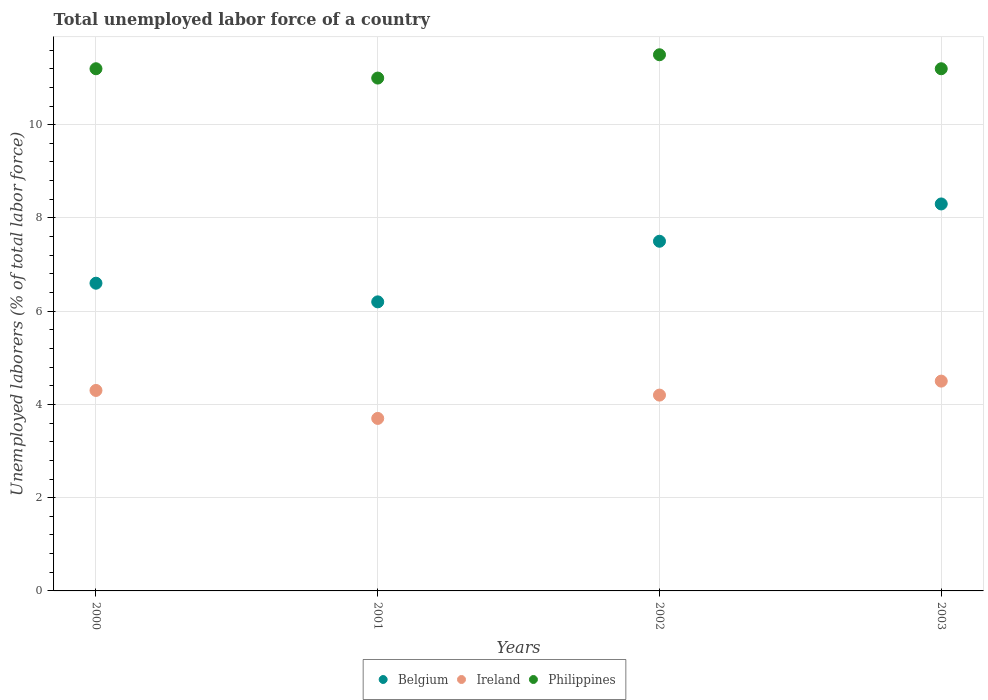How many different coloured dotlines are there?
Your answer should be compact. 3. What is the total unemployed labor force in Ireland in 2000?
Offer a terse response. 4.3. Across all years, what is the maximum total unemployed labor force in Belgium?
Ensure brevity in your answer.  8.3. In which year was the total unemployed labor force in Philippines minimum?
Offer a very short reply. 2001. What is the total total unemployed labor force in Philippines in the graph?
Make the answer very short. 44.9. What is the difference between the total unemployed labor force in Philippines in 2000 and that in 2002?
Your response must be concise. -0.3. What is the difference between the total unemployed labor force in Ireland in 2002 and the total unemployed labor force in Philippines in 2003?
Make the answer very short. -7. What is the average total unemployed labor force in Belgium per year?
Your response must be concise. 7.15. In the year 2000, what is the difference between the total unemployed labor force in Belgium and total unemployed labor force in Philippines?
Give a very brief answer. -4.6. In how many years, is the total unemployed labor force in Philippines greater than 10.4 %?
Your response must be concise. 4. What is the ratio of the total unemployed labor force in Philippines in 2001 to that in 2003?
Make the answer very short. 0.98. Is the difference between the total unemployed labor force in Belgium in 2000 and 2002 greater than the difference between the total unemployed labor force in Philippines in 2000 and 2002?
Provide a succinct answer. No. What is the difference between the highest and the second highest total unemployed labor force in Belgium?
Your answer should be compact. 0.8. What is the difference between the highest and the lowest total unemployed labor force in Belgium?
Your answer should be very brief. 2.1. Is the sum of the total unemployed labor force in Ireland in 2001 and 2002 greater than the maximum total unemployed labor force in Philippines across all years?
Offer a very short reply. No. Is it the case that in every year, the sum of the total unemployed labor force in Philippines and total unemployed labor force in Ireland  is greater than the total unemployed labor force in Belgium?
Keep it short and to the point. Yes. Does the total unemployed labor force in Ireland monotonically increase over the years?
Keep it short and to the point. No. How many years are there in the graph?
Your answer should be very brief. 4. What is the difference between two consecutive major ticks on the Y-axis?
Your answer should be very brief. 2. Are the values on the major ticks of Y-axis written in scientific E-notation?
Your answer should be very brief. No. Where does the legend appear in the graph?
Offer a terse response. Bottom center. What is the title of the graph?
Your response must be concise. Total unemployed labor force of a country. Does "Bermuda" appear as one of the legend labels in the graph?
Keep it short and to the point. No. What is the label or title of the X-axis?
Offer a very short reply. Years. What is the label or title of the Y-axis?
Offer a terse response. Unemployed laborers (% of total labor force). What is the Unemployed laborers (% of total labor force) in Belgium in 2000?
Ensure brevity in your answer.  6.6. What is the Unemployed laborers (% of total labor force) of Ireland in 2000?
Your answer should be compact. 4.3. What is the Unemployed laborers (% of total labor force) in Philippines in 2000?
Your answer should be compact. 11.2. What is the Unemployed laborers (% of total labor force) of Belgium in 2001?
Provide a succinct answer. 6.2. What is the Unemployed laborers (% of total labor force) in Ireland in 2001?
Your answer should be very brief. 3.7. What is the Unemployed laborers (% of total labor force) of Ireland in 2002?
Keep it short and to the point. 4.2. What is the Unemployed laborers (% of total labor force) in Philippines in 2002?
Offer a very short reply. 11.5. What is the Unemployed laborers (% of total labor force) in Belgium in 2003?
Provide a succinct answer. 8.3. What is the Unemployed laborers (% of total labor force) in Ireland in 2003?
Keep it short and to the point. 4.5. What is the Unemployed laborers (% of total labor force) of Philippines in 2003?
Keep it short and to the point. 11.2. Across all years, what is the maximum Unemployed laborers (% of total labor force) of Belgium?
Offer a very short reply. 8.3. Across all years, what is the maximum Unemployed laborers (% of total labor force) of Ireland?
Offer a terse response. 4.5. Across all years, what is the maximum Unemployed laborers (% of total labor force) in Philippines?
Ensure brevity in your answer.  11.5. Across all years, what is the minimum Unemployed laborers (% of total labor force) in Belgium?
Provide a succinct answer. 6.2. Across all years, what is the minimum Unemployed laborers (% of total labor force) of Ireland?
Your answer should be very brief. 3.7. What is the total Unemployed laborers (% of total labor force) of Belgium in the graph?
Make the answer very short. 28.6. What is the total Unemployed laborers (% of total labor force) in Ireland in the graph?
Make the answer very short. 16.7. What is the total Unemployed laborers (% of total labor force) in Philippines in the graph?
Your answer should be very brief. 44.9. What is the difference between the Unemployed laborers (% of total labor force) of Belgium in 2000 and that in 2002?
Provide a succinct answer. -0.9. What is the difference between the Unemployed laborers (% of total labor force) of Belgium in 2000 and that in 2003?
Give a very brief answer. -1.7. What is the difference between the Unemployed laborers (% of total labor force) of Ireland in 2000 and that in 2003?
Make the answer very short. -0.2. What is the difference between the Unemployed laborers (% of total labor force) of Belgium in 2001 and that in 2002?
Offer a terse response. -1.3. What is the difference between the Unemployed laborers (% of total labor force) in Ireland in 2001 and that in 2002?
Offer a very short reply. -0.5. What is the difference between the Unemployed laborers (% of total labor force) in Philippines in 2001 and that in 2002?
Your response must be concise. -0.5. What is the difference between the Unemployed laborers (% of total labor force) in Belgium in 2002 and that in 2003?
Ensure brevity in your answer.  -0.8. What is the difference between the Unemployed laborers (% of total labor force) in Belgium in 2000 and the Unemployed laborers (% of total labor force) in Ireland in 2001?
Provide a short and direct response. 2.9. What is the difference between the Unemployed laborers (% of total labor force) in Belgium in 2000 and the Unemployed laborers (% of total labor force) in Ireland in 2002?
Offer a terse response. 2.4. What is the difference between the Unemployed laborers (% of total labor force) of Ireland in 2000 and the Unemployed laborers (% of total labor force) of Philippines in 2002?
Provide a succinct answer. -7.2. What is the difference between the Unemployed laborers (% of total labor force) of Ireland in 2000 and the Unemployed laborers (% of total labor force) of Philippines in 2003?
Offer a terse response. -6.9. What is the difference between the Unemployed laborers (% of total labor force) of Belgium in 2001 and the Unemployed laborers (% of total labor force) of Ireland in 2002?
Make the answer very short. 2. What is the difference between the Unemployed laborers (% of total labor force) in Belgium in 2001 and the Unemployed laborers (% of total labor force) in Philippines in 2002?
Keep it short and to the point. -5.3. What is the difference between the Unemployed laborers (% of total labor force) in Belgium in 2001 and the Unemployed laborers (% of total labor force) in Philippines in 2003?
Offer a terse response. -5. What is the difference between the Unemployed laborers (% of total labor force) in Ireland in 2001 and the Unemployed laborers (% of total labor force) in Philippines in 2003?
Provide a short and direct response. -7.5. What is the difference between the Unemployed laborers (% of total labor force) of Belgium in 2002 and the Unemployed laborers (% of total labor force) of Ireland in 2003?
Your answer should be very brief. 3. What is the average Unemployed laborers (% of total labor force) of Belgium per year?
Your response must be concise. 7.15. What is the average Unemployed laborers (% of total labor force) in Ireland per year?
Make the answer very short. 4.17. What is the average Unemployed laborers (% of total labor force) of Philippines per year?
Provide a short and direct response. 11.22. In the year 2000, what is the difference between the Unemployed laborers (% of total labor force) of Belgium and Unemployed laborers (% of total labor force) of Philippines?
Offer a terse response. -4.6. In the year 2000, what is the difference between the Unemployed laborers (% of total labor force) in Ireland and Unemployed laborers (% of total labor force) in Philippines?
Your answer should be compact. -6.9. In the year 2001, what is the difference between the Unemployed laborers (% of total labor force) of Belgium and Unemployed laborers (% of total labor force) of Ireland?
Offer a very short reply. 2.5. In the year 2001, what is the difference between the Unemployed laborers (% of total labor force) of Belgium and Unemployed laborers (% of total labor force) of Philippines?
Provide a short and direct response. -4.8. In the year 2001, what is the difference between the Unemployed laborers (% of total labor force) in Ireland and Unemployed laborers (% of total labor force) in Philippines?
Keep it short and to the point. -7.3. In the year 2002, what is the difference between the Unemployed laborers (% of total labor force) of Ireland and Unemployed laborers (% of total labor force) of Philippines?
Offer a terse response. -7.3. In the year 2003, what is the difference between the Unemployed laborers (% of total labor force) of Ireland and Unemployed laborers (% of total labor force) of Philippines?
Offer a terse response. -6.7. What is the ratio of the Unemployed laborers (% of total labor force) of Belgium in 2000 to that in 2001?
Your answer should be very brief. 1.06. What is the ratio of the Unemployed laborers (% of total labor force) in Ireland in 2000 to that in 2001?
Provide a short and direct response. 1.16. What is the ratio of the Unemployed laborers (% of total labor force) of Philippines in 2000 to that in 2001?
Give a very brief answer. 1.02. What is the ratio of the Unemployed laborers (% of total labor force) of Ireland in 2000 to that in 2002?
Ensure brevity in your answer.  1.02. What is the ratio of the Unemployed laborers (% of total labor force) in Philippines in 2000 to that in 2002?
Keep it short and to the point. 0.97. What is the ratio of the Unemployed laborers (% of total labor force) of Belgium in 2000 to that in 2003?
Provide a succinct answer. 0.8. What is the ratio of the Unemployed laborers (% of total labor force) in Ireland in 2000 to that in 2003?
Ensure brevity in your answer.  0.96. What is the ratio of the Unemployed laborers (% of total labor force) of Philippines in 2000 to that in 2003?
Your response must be concise. 1. What is the ratio of the Unemployed laborers (% of total labor force) of Belgium in 2001 to that in 2002?
Provide a short and direct response. 0.83. What is the ratio of the Unemployed laborers (% of total labor force) of Ireland in 2001 to that in 2002?
Offer a terse response. 0.88. What is the ratio of the Unemployed laborers (% of total labor force) in Philippines in 2001 to that in 2002?
Ensure brevity in your answer.  0.96. What is the ratio of the Unemployed laborers (% of total labor force) of Belgium in 2001 to that in 2003?
Make the answer very short. 0.75. What is the ratio of the Unemployed laborers (% of total labor force) of Ireland in 2001 to that in 2003?
Offer a terse response. 0.82. What is the ratio of the Unemployed laborers (% of total labor force) in Philippines in 2001 to that in 2003?
Offer a very short reply. 0.98. What is the ratio of the Unemployed laborers (% of total labor force) of Belgium in 2002 to that in 2003?
Your answer should be compact. 0.9. What is the ratio of the Unemployed laborers (% of total labor force) in Ireland in 2002 to that in 2003?
Offer a terse response. 0.93. What is the ratio of the Unemployed laborers (% of total labor force) of Philippines in 2002 to that in 2003?
Your response must be concise. 1.03. What is the difference between the highest and the second highest Unemployed laborers (% of total labor force) of Ireland?
Provide a short and direct response. 0.2. What is the difference between the highest and the second highest Unemployed laborers (% of total labor force) of Philippines?
Make the answer very short. 0.3. What is the difference between the highest and the lowest Unemployed laborers (% of total labor force) in Belgium?
Your response must be concise. 2.1. What is the difference between the highest and the lowest Unemployed laborers (% of total labor force) of Ireland?
Your response must be concise. 0.8. What is the difference between the highest and the lowest Unemployed laborers (% of total labor force) of Philippines?
Ensure brevity in your answer.  0.5. 